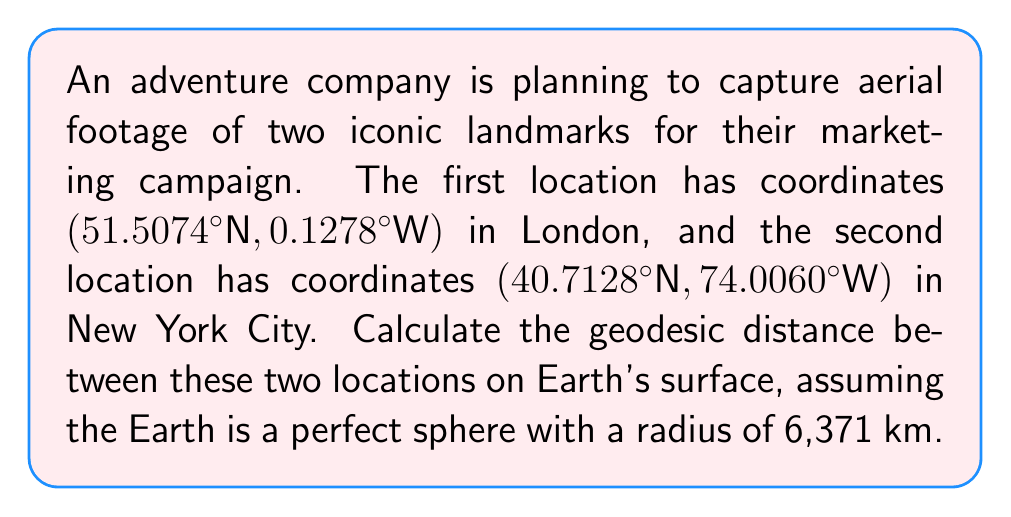Solve this math problem. To calculate the geodesic distance between two points on Earth's surface, we'll use the Haversine formula:

1) Convert the latitude and longitude coordinates from degrees to radians:
   $$\phi_1 = 51.5074° \times \frac{\pi}{180} = 0.8990 \text{ rad}$$
   $$\lambda_1 = -0.1278° \times \frac{\pi}{180} = -0.0022 \text{ rad}$$
   $$\phi_2 = 40.7128° \times \frac{\pi}{180} = 0.7104 \text{ rad}$$
   $$\lambda_2 = -74.0060° \times \frac{\pi}{180} = -1.2917 \text{ rad}$$

2) Calculate the difference in longitude:
   $$\Delta\lambda = \lambda_2 - \lambda_1 = -1.2895 \text{ rad}$$

3) Apply the Haversine formula:
   $$a = \sin^2\left(\frac{\phi_2 - \phi_1}{2}\right) + \cos(\phi_1)\cos(\phi_2)\sin^2\left(\frac{\Delta\lambda}{2}\right)$$
   $$a = \sin^2\left(\frac{0.7104 - 0.8990}{2}\right) + \cos(0.8990)\cos(0.7104)\sin^2\left(\frac{-1.2895}{2}\right)$$
   $$a = 0.3919$$

4) Calculate the central angle:
   $$c = 2 \times \arctan2(\sqrt{a}, \sqrt{1-a}) = 1.3348 \text{ rad}$$

5) Compute the geodesic distance:
   $$d = R \times c$$
   where R is the Earth's radius (6,371 km)
   $$d = 6371 \times 1.3348 = 8503.5 \text{ km}$$

Therefore, the geodesic distance between London and New York City is approximately 8503.5 km.
Answer: 8503.5 km 